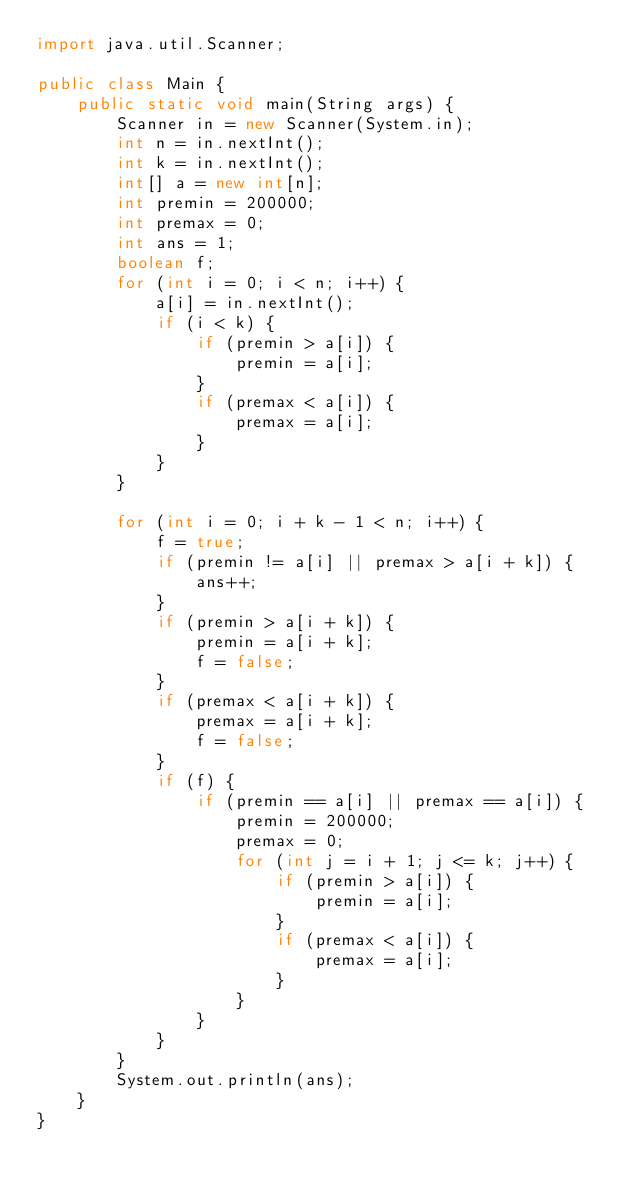<code> <loc_0><loc_0><loc_500><loc_500><_Java_>import java.util.Scanner;

public class Main {
    public static void main(String args) {
        Scanner in = new Scanner(System.in);
        int n = in.nextInt();
        int k = in.nextInt();
        int[] a = new int[n];
        int premin = 200000;
        int premax = 0;
        int ans = 1;
        boolean f;
        for (int i = 0; i < n; i++) {
            a[i] = in.nextInt();
            if (i < k) {
                if (premin > a[i]) {
                    premin = a[i];
                }
                if (premax < a[i]) {
                    premax = a[i];
                }
            }
        }

        for (int i = 0; i + k - 1 < n; i++) {
            f = true;
            if (premin != a[i] || premax > a[i + k]) {
                ans++;
            }
            if (premin > a[i + k]) {
                premin = a[i + k];
                f = false;
            }
            if (premax < a[i + k]) {
                premax = a[i + k];
                f = false;
            }
            if (f) {
                if (premin == a[i] || premax == a[i]) {
                    premin = 200000;
                    premax = 0;
                    for (int j = i + 1; j <= k; j++) {
                        if (premin > a[i]) {
                            premin = a[i];
                        }
                        if (premax < a[i]) {
                            premax = a[i];
                        }
                    }
                }
            }
        }
        System.out.println(ans);
    }
}</code> 